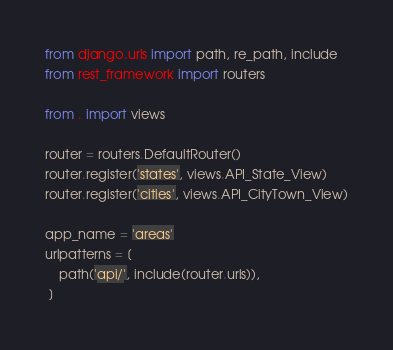<code> <loc_0><loc_0><loc_500><loc_500><_Python_>from django.urls import path, re_path, include
from rest_framework import routers

from . import views

router = routers.DefaultRouter()
router.register('states', views.API_State_View)
router.register('cities', views.API_CityTown_View)

app_name = 'areas'
urlpatterns = [
    path('api/', include(router.urls)),
 ]
</code> 